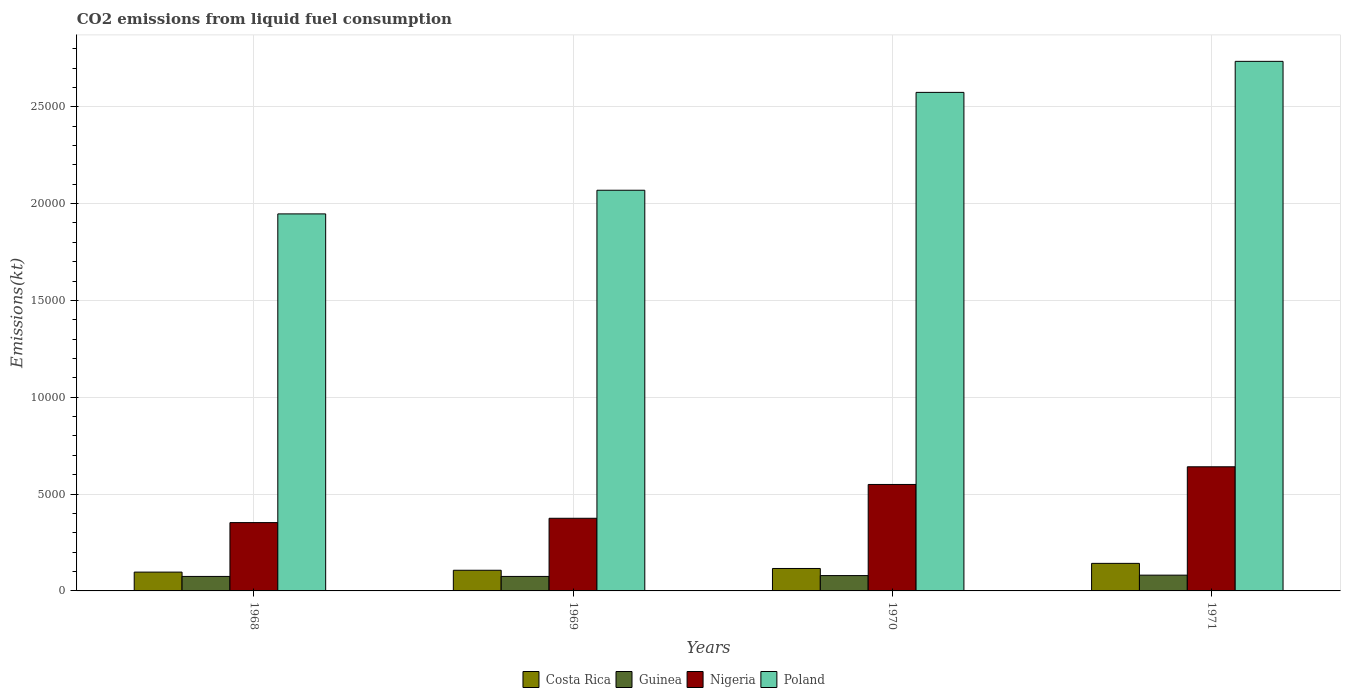Are the number of bars per tick equal to the number of legend labels?
Ensure brevity in your answer.  Yes. Are the number of bars on each tick of the X-axis equal?
Make the answer very short. Yes. How many bars are there on the 4th tick from the left?
Offer a very short reply. 4. What is the label of the 2nd group of bars from the left?
Your response must be concise. 1969. In how many cases, is the number of bars for a given year not equal to the number of legend labels?
Offer a very short reply. 0. What is the amount of CO2 emitted in Nigeria in 1968?
Offer a very short reply. 3527.65. Across all years, what is the maximum amount of CO2 emitted in Guinea?
Your answer should be compact. 814.07. Across all years, what is the minimum amount of CO2 emitted in Guinea?
Provide a short and direct response. 748.07. In which year was the amount of CO2 emitted in Poland minimum?
Ensure brevity in your answer.  1968. What is the total amount of CO2 emitted in Nigeria in the graph?
Provide a succinct answer. 1.92e+04. What is the difference between the amount of CO2 emitted in Guinea in 1968 and that in 1971?
Your answer should be very brief. -66.01. What is the difference between the amount of CO2 emitted in Poland in 1968 and the amount of CO2 emitted in Guinea in 1970?
Offer a very short reply. 1.87e+04. What is the average amount of CO2 emitted in Poland per year?
Ensure brevity in your answer.  2.33e+04. In the year 1968, what is the difference between the amount of CO2 emitted in Costa Rica and amount of CO2 emitted in Guinea?
Provide a succinct answer. 223.69. In how many years, is the amount of CO2 emitted in Poland greater than 7000 kt?
Make the answer very short. 4. What is the ratio of the amount of CO2 emitted in Guinea in 1968 to that in 1970?
Ensure brevity in your answer.  0.94. Is the amount of CO2 emitted in Guinea in 1968 less than that in 1969?
Keep it short and to the point. No. What is the difference between the highest and the second highest amount of CO2 emitted in Guinea?
Make the answer very short. 22. What is the difference between the highest and the lowest amount of CO2 emitted in Nigeria?
Keep it short and to the point. 2882.26. In how many years, is the amount of CO2 emitted in Costa Rica greater than the average amount of CO2 emitted in Costa Rica taken over all years?
Provide a succinct answer. 2. Is it the case that in every year, the sum of the amount of CO2 emitted in Poland and amount of CO2 emitted in Costa Rica is greater than the sum of amount of CO2 emitted in Guinea and amount of CO2 emitted in Nigeria?
Your answer should be compact. Yes. What does the 2nd bar from the right in 1971 represents?
Keep it short and to the point. Nigeria. Are all the bars in the graph horizontal?
Keep it short and to the point. No. How many years are there in the graph?
Ensure brevity in your answer.  4. What is the difference between two consecutive major ticks on the Y-axis?
Offer a terse response. 5000. Are the values on the major ticks of Y-axis written in scientific E-notation?
Your answer should be very brief. No. How many legend labels are there?
Your response must be concise. 4. What is the title of the graph?
Ensure brevity in your answer.  CO2 emissions from liquid fuel consumption. What is the label or title of the Y-axis?
Your answer should be very brief. Emissions(kt). What is the Emissions(kt) in Costa Rica in 1968?
Provide a succinct answer. 971.75. What is the Emissions(kt) of Guinea in 1968?
Offer a very short reply. 748.07. What is the Emissions(kt) in Nigeria in 1968?
Your answer should be very brief. 3527.65. What is the Emissions(kt) in Poland in 1968?
Make the answer very short. 1.95e+04. What is the Emissions(kt) of Costa Rica in 1969?
Your response must be concise. 1067.1. What is the Emissions(kt) of Guinea in 1969?
Ensure brevity in your answer.  748.07. What is the Emissions(kt) in Nigeria in 1969?
Provide a succinct answer. 3751.34. What is the Emissions(kt) in Poland in 1969?
Ensure brevity in your answer.  2.07e+04. What is the Emissions(kt) of Costa Rica in 1970?
Your answer should be compact. 1158.77. What is the Emissions(kt) in Guinea in 1970?
Ensure brevity in your answer.  792.07. What is the Emissions(kt) of Nigeria in 1970?
Provide a succinct answer. 5496.83. What is the Emissions(kt) of Poland in 1970?
Provide a succinct answer. 2.57e+04. What is the Emissions(kt) in Costa Rica in 1971?
Your answer should be very brief. 1422.8. What is the Emissions(kt) in Guinea in 1971?
Make the answer very short. 814.07. What is the Emissions(kt) in Nigeria in 1971?
Offer a very short reply. 6409.92. What is the Emissions(kt) of Poland in 1971?
Provide a succinct answer. 2.73e+04. Across all years, what is the maximum Emissions(kt) of Costa Rica?
Provide a short and direct response. 1422.8. Across all years, what is the maximum Emissions(kt) in Guinea?
Provide a short and direct response. 814.07. Across all years, what is the maximum Emissions(kt) of Nigeria?
Provide a succinct answer. 6409.92. Across all years, what is the maximum Emissions(kt) in Poland?
Your answer should be compact. 2.73e+04. Across all years, what is the minimum Emissions(kt) in Costa Rica?
Keep it short and to the point. 971.75. Across all years, what is the minimum Emissions(kt) of Guinea?
Offer a terse response. 748.07. Across all years, what is the minimum Emissions(kt) of Nigeria?
Your answer should be very brief. 3527.65. Across all years, what is the minimum Emissions(kt) of Poland?
Make the answer very short. 1.95e+04. What is the total Emissions(kt) in Costa Rica in the graph?
Keep it short and to the point. 4620.42. What is the total Emissions(kt) of Guinea in the graph?
Keep it short and to the point. 3102.28. What is the total Emissions(kt) in Nigeria in the graph?
Your answer should be very brief. 1.92e+04. What is the total Emissions(kt) in Poland in the graph?
Your response must be concise. 9.32e+04. What is the difference between the Emissions(kt) of Costa Rica in 1968 and that in 1969?
Your response must be concise. -95.34. What is the difference between the Emissions(kt) in Guinea in 1968 and that in 1969?
Your answer should be very brief. 0. What is the difference between the Emissions(kt) in Nigeria in 1968 and that in 1969?
Offer a very short reply. -223.69. What is the difference between the Emissions(kt) of Poland in 1968 and that in 1969?
Make the answer very short. -1221.11. What is the difference between the Emissions(kt) in Costa Rica in 1968 and that in 1970?
Your answer should be very brief. -187.02. What is the difference between the Emissions(kt) in Guinea in 1968 and that in 1970?
Make the answer very short. -44. What is the difference between the Emissions(kt) in Nigeria in 1968 and that in 1970?
Give a very brief answer. -1969.18. What is the difference between the Emissions(kt) in Poland in 1968 and that in 1970?
Your answer should be very brief. -6274.24. What is the difference between the Emissions(kt) in Costa Rica in 1968 and that in 1971?
Your answer should be very brief. -451.04. What is the difference between the Emissions(kt) in Guinea in 1968 and that in 1971?
Ensure brevity in your answer.  -66.01. What is the difference between the Emissions(kt) of Nigeria in 1968 and that in 1971?
Make the answer very short. -2882.26. What is the difference between the Emissions(kt) of Poland in 1968 and that in 1971?
Make the answer very short. -7876.72. What is the difference between the Emissions(kt) in Costa Rica in 1969 and that in 1970?
Offer a terse response. -91.67. What is the difference between the Emissions(kt) in Guinea in 1969 and that in 1970?
Provide a succinct answer. -44. What is the difference between the Emissions(kt) of Nigeria in 1969 and that in 1970?
Your answer should be compact. -1745.49. What is the difference between the Emissions(kt) in Poland in 1969 and that in 1970?
Make the answer very short. -5053.13. What is the difference between the Emissions(kt) in Costa Rica in 1969 and that in 1971?
Provide a succinct answer. -355.7. What is the difference between the Emissions(kt) in Guinea in 1969 and that in 1971?
Offer a very short reply. -66.01. What is the difference between the Emissions(kt) in Nigeria in 1969 and that in 1971?
Your answer should be compact. -2658.57. What is the difference between the Emissions(kt) of Poland in 1969 and that in 1971?
Offer a terse response. -6655.6. What is the difference between the Emissions(kt) in Costa Rica in 1970 and that in 1971?
Provide a short and direct response. -264.02. What is the difference between the Emissions(kt) of Guinea in 1970 and that in 1971?
Offer a terse response. -22. What is the difference between the Emissions(kt) in Nigeria in 1970 and that in 1971?
Your answer should be compact. -913.08. What is the difference between the Emissions(kt) in Poland in 1970 and that in 1971?
Offer a very short reply. -1602.48. What is the difference between the Emissions(kt) in Costa Rica in 1968 and the Emissions(kt) in Guinea in 1969?
Your answer should be compact. 223.69. What is the difference between the Emissions(kt) of Costa Rica in 1968 and the Emissions(kt) of Nigeria in 1969?
Provide a short and direct response. -2779.59. What is the difference between the Emissions(kt) of Costa Rica in 1968 and the Emissions(kt) of Poland in 1969?
Offer a terse response. -1.97e+04. What is the difference between the Emissions(kt) of Guinea in 1968 and the Emissions(kt) of Nigeria in 1969?
Provide a succinct answer. -3003.27. What is the difference between the Emissions(kt) in Guinea in 1968 and the Emissions(kt) in Poland in 1969?
Provide a succinct answer. -1.99e+04. What is the difference between the Emissions(kt) in Nigeria in 1968 and the Emissions(kt) in Poland in 1969?
Provide a succinct answer. -1.72e+04. What is the difference between the Emissions(kt) in Costa Rica in 1968 and the Emissions(kt) in Guinea in 1970?
Give a very brief answer. 179.68. What is the difference between the Emissions(kt) in Costa Rica in 1968 and the Emissions(kt) in Nigeria in 1970?
Your answer should be very brief. -4525.08. What is the difference between the Emissions(kt) in Costa Rica in 1968 and the Emissions(kt) in Poland in 1970?
Offer a very short reply. -2.48e+04. What is the difference between the Emissions(kt) in Guinea in 1968 and the Emissions(kt) in Nigeria in 1970?
Provide a succinct answer. -4748.77. What is the difference between the Emissions(kt) of Guinea in 1968 and the Emissions(kt) of Poland in 1970?
Your response must be concise. -2.50e+04. What is the difference between the Emissions(kt) of Nigeria in 1968 and the Emissions(kt) of Poland in 1970?
Offer a very short reply. -2.22e+04. What is the difference between the Emissions(kt) in Costa Rica in 1968 and the Emissions(kt) in Guinea in 1971?
Keep it short and to the point. 157.68. What is the difference between the Emissions(kt) in Costa Rica in 1968 and the Emissions(kt) in Nigeria in 1971?
Make the answer very short. -5438.16. What is the difference between the Emissions(kt) of Costa Rica in 1968 and the Emissions(kt) of Poland in 1971?
Your answer should be compact. -2.64e+04. What is the difference between the Emissions(kt) in Guinea in 1968 and the Emissions(kt) in Nigeria in 1971?
Keep it short and to the point. -5661.85. What is the difference between the Emissions(kt) of Guinea in 1968 and the Emissions(kt) of Poland in 1971?
Offer a terse response. -2.66e+04. What is the difference between the Emissions(kt) of Nigeria in 1968 and the Emissions(kt) of Poland in 1971?
Your answer should be very brief. -2.38e+04. What is the difference between the Emissions(kt) of Costa Rica in 1969 and the Emissions(kt) of Guinea in 1970?
Ensure brevity in your answer.  275.02. What is the difference between the Emissions(kt) in Costa Rica in 1969 and the Emissions(kt) in Nigeria in 1970?
Provide a short and direct response. -4429.74. What is the difference between the Emissions(kt) of Costa Rica in 1969 and the Emissions(kt) of Poland in 1970?
Ensure brevity in your answer.  -2.47e+04. What is the difference between the Emissions(kt) in Guinea in 1969 and the Emissions(kt) in Nigeria in 1970?
Ensure brevity in your answer.  -4748.77. What is the difference between the Emissions(kt) in Guinea in 1969 and the Emissions(kt) in Poland in 1970?
Your answer should be very brief. -2.50e+04. What is the difference between the Emissions(kt) of Nigeria in 1969 and the Emissions(kt) of Poland in 1970?
Offer a terse response. -2.20e+04. What is the difference between the Emissions(kt) of Costa Rica in 1969 and the Emissions(kt) of Guinea in 1971?
Make the answer very short. 253.02. What is the difference between the Emissions(kt) in Costa Rica in 1969 and the Emissions(kt) in Nigeria in 1971?
Offer a terse response. -5342.82. What is the difference between the Emissions(kt) in Costa Rica in 1969 and the Emissions(kt) in Poland in 1971?
Keep it short and to the point. -2.63e+04. What is the difference between the Emissions(kt) in Guinea in 1969 and the Emissions(kt) in Nigeria in 1971?
Keep it short and to the point. -5661.85. What is the difference between the Emissions(kt) of Guinea in 1969 and the Emissions(kt) of Poland in 1971?
Give a very brief answer. -2.66e+04. What is the difference between the Emissions(kt) in Nigeria in 1969 and the Emissions(kt) in Poland in 1971?
Your answer should be compact. -2.36e+04. What is the difference between the Emissions(kt) in Costa Rica in 1970 and the Emissions(kt) in Guinea in 1971?
Offer a very short reply. 344.7. What is the difference between the Emissions(kt) in Costa Rica in 1970 and the Emissions(kt) in Nigeria in 1971?
Your response must be concise. -5251.14. What is the difference between the Emissions(kt) in Costa Rica in 1970 and the Emissions(kt) in Poland in 1971?
Make the answer very short. -2.62e+04. What is the difference between the Emissions(kt) in Guinea in 1970 and the Emissions(kt) in Nigeria in 1971?
Provide a succinct answer. -5617.84. What is the difference between the Emissions(kt) of Guinea in 1970 and the Emissions(kt) of Poland in 1971?
Make the answer very short. -2.66e+04. What is the difference between the Emissions(kt) of Nigeria in 1970 and the Emissions(kt) of Poland in 1971?
Your response must be concise. -2.18e+04. What is the average Emissions(kt) of Costa Rica per year?
Make the answer very short. 1155.11. What is the average Emissions(kt) of Guinea per year?
Give a very brief answer. 775.57. What is the average Emissions(kt) of Nigeria per year?
Make the answer very short. 4796.44. What is the average Emissions(kt) of Poland per year?
Give a very brief answer. 2.33e+04. In the year 1968, what is the difference between the Emissions(kt) in Costa Rica and Emissions(kt) in Guinea?
Keep it short and to the point. 223.69. In the year 1968, what is the difference between the Emissions(kt) in Costa Rica and Emissions(kt) in Nigeria?
Your response must be concise. -2555.9. In the year 1968, what is the difference between the Emissions(kt) of Costa Rica and Emissions(kt) of Poland?
Your answer should be very brief. -1.85e+04. In the year 1968, what is the difference between the Emissions(kt) in Guinea and Emissions(kt) in Nigeria?
Ensure brevity in your answer.  -2779.59. In the year 1968, what is the difference between the Emissions(kt) in Guinea and Emissions(kt) in Poland?
Your answer should be very brief. -1.87e+04. In the year 1968, what is the difference between the Emissions(kt) in Nigeria and Emissions(kt) in Poland?
Give a very brief answer. -1.59e+04. In the year 1969, what is the difference between the Emissions(kt) in Costa Rica and Emissions(kt) in Guinea?
Ensure brevity in your answer.  319.03. In the year 1969, what is the difference between the Emissions(kt) in Costa Rica and Emissions(kt) in Nigeria?
Offer a terse response. -2684.24. In the year 1969, what is the difference between the Emissions(kt) of Costa Rica and Emissions(kt) of Poland?
Make the answer very short. -1.96e+04. In the year 1969, what is the difference between the Emissions(kt) of Guinea and Emissions(kt) of Nigeria?
Your response must be concise. -3003.27. In the year 1969, what is the difference between the Emissions(kt) of Guinea and Emissions(kt) of Poland?
Your answer should be very brief. -1.99e+04. In the year 1969, what is the difference between the Emissions(kt) in Nigeria and Emissions(kt) in Poland?
Your response must be concise. -1.69e+04. In the year 1970, what is the difference between the Emissions(kt) in Costa Rica and Emissions(kt) in Guinea?
Give a very brief answer. 366.7. In the year 1970, what is the difference between the Emissions(kt) of Costa Rica and Emissions(kt) of Nigeria?
Ensure brevity in your answer.  -4338.06. In the year 1970, what is the difference between the Emissions(kt) in Costa Rica and Emissions(kt) in Poland?
Give a very brief answer. -2.46e+04. In the year 1970, what is the difference between the Emissions(kt) in Guinea and Emissions(kt) in Nigeria?
Make the answer very short. -4704.76. In the year 1970, what is the difference between the Emissions(kt) in Guinea and Emissions(kt) in Poland?
Your response must be concise. -2.50e+04. In the year 1970, what is the difference between the Emissions(kt) of Nigeria and Emissions(kt) of Poland?
Provide a short and direct response. -2.02e+04. In the year 1971, what is the difference between the Emissions(kt) in Costa Rica and Emissions(kt) in Guinea?
Offer a terse response. 608.72. In the year 1971, what is the difference between the Emissions(kt) of Costa Rica and Emissions(kt) of Nigeria?
Offer a terse response. -4987.12. In the year 1971, what is the difference between the Emissions(kt) in Costa Rica and Emissions(kt) in Poland?
Ensure brevity in your answer.  -2.59e+04. In the year 1971, what is the difference between the Emissions(kt) of Guinea and Emissions(kt) of Nigeria?
Make the answer very short. -5595.84. In the year 1971, what is the difference between the Emissions(kt) in Guinea and Emissions(kt) in Poland?
Give a very brief answer. -2.65e+04. In the year 1971, what is the difference between the Emissions(kt) in Nigeria and Emissions(kt) in Poland?
Give a very brief answer. -2.09e+04. What is the ratio of the Emissions(kt) in Costa Rica in 1968 to that in 1969?
Provide a succinct answer. 0.91. What is the ratio of the Emissions(kt) of Nigeria in 1968 to that in 1969?
Offer a terse response. 0.94. What is the ratio of the Emissions(kt) of Poland in 1968 to that in 1969?
Your response must be concise. 0.94. What is the ratio of the Emissions(kt) of Costa Rica in 1968 to that in 1970?
Your answer should be compact. 0.84. What is the ratio of the Emissions(kt) in Nigeria in 1968 to that in 1970?
Make the answer very short. 0.64. What is the ratio of the Emissions(kt) of Poland in 1968 to that in 1970?
Your response must be concise. 0.76. What is the ratio of the Emissions(kt) in Costa Rica in 1968 to that in 1971?
Your answer should be compact. 0.68. What is the ratio of the Emissions(kt) in Guinea in 1968 to that in 1971?
Your response must be concise. 0.92. What is the ratio of the Emissions(kt) of Nigeria in 1968 to that in 1971?
Offer a very short reply. 0.55. What is the ratio of the Emissions(kt) of Poland in 1968 to that in 1971?
Keep it short and to the point. 0.71. What is the ratio of the Emissions(kt) of Costa Rica in 1969 to that in 1970?
Provide a succinct answer. 0.92. What is the ratio of the Emissions(kt) of Nigeria in 1969 to that in 1970?
Your answer should be compact. 0.68. What is the ratio of the Emissions(kt) of Poland in 1969 to that in 1970?
Ensure brevity in your answer.  0.8. What is the ratio of the Emissions(kt) in Costa Rica in 1969 to that in 1971?
Your answer should be compact. 0.75. What is the ratio of the Emissions(kt) of Guinea in 1969 to that in 1971?
Offer a terse response. 0.92. What is the ratio of the Emissions(kt) in Nigeria in 1969 to that in 1971?
Ensure brevity in your answer.  0.59. What is the ratio of the Emissions(kt) of Poland in 1969 to that in 1971?
Ensure brevity in your answer.  0.76. What is the ratio of the Emissions(kt) of Costa Rica in 1970 to that in 1971?
Give a very brief answer. 0.81. What is the ratio of the Emissions(kt) of Nigeria in 1970 to that in 1971?
Give a very brief answer. 0.86. What is the ratio of the Emissions(kt) of Poland in 1970 to that in 1971?
Keep it short and to the point. 0.94. What is the difference between the highest and the second highest Emissions(kt) of Costa Rica?
Make the answer very short. 264.02. What is the difference between the highest and the second highest Emissions(kt) in Guinea?
Offer a terse response. 22. What is the difference between the highest and the second highest Emissions(kt) of Nigeria?
Your answer should be compact. 913.08. What is the difference between the highest and the second highest Emissions(kt) in Poland?
Your answer should be compact. 1602.48. What is the difference between the highest and the lowest Emissions(kt) in Costa Rica?
Provide a succinct answer. 451.04. What is the difference between the highest and the lowest Emissions(kt) in Guinea?
Make the answer very short. 66.01. What is the difference between the highest and the lowest Emissions(kt) of Nigeria?
Make the answer very short. 2882.26. What is the difference between the highest and the lowest Emissions(kt) in Poland?
Give a very brief answer. 7876.72. 